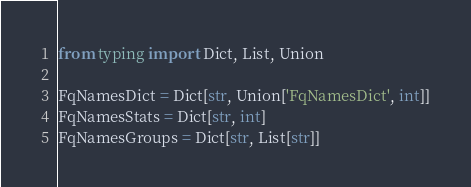Convert code to text. <code><loc_0><loc_0><loc_500><loc_500><_Python_>from typing import Dict, List, Union

FqNamesDict = Dict[str, Union['FqNamesDict', int]]
FqNamesStats = Dict[str, int]
FqNamesGroups = Dict[str, List[str]]
</code> 